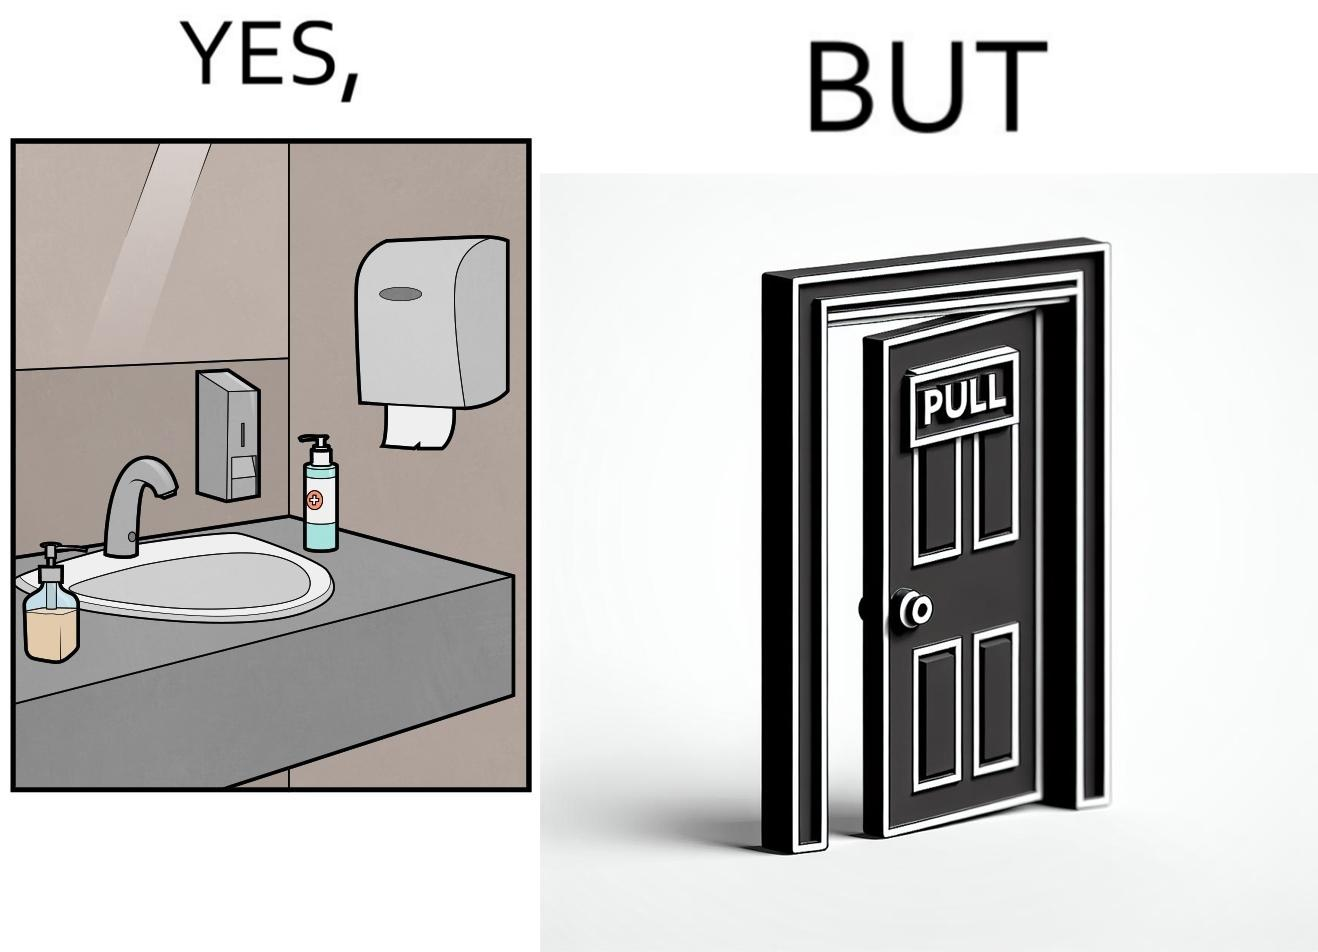Explain the humor or irony in this image. The image is ironic, because in the first image in the bathroom there are so many things to clean hands around the basin but in the same bathroom people have to open the doors by hand which can easily spread the germs or bacteria even after times of hand cleaning as there is no way to open it without hands 